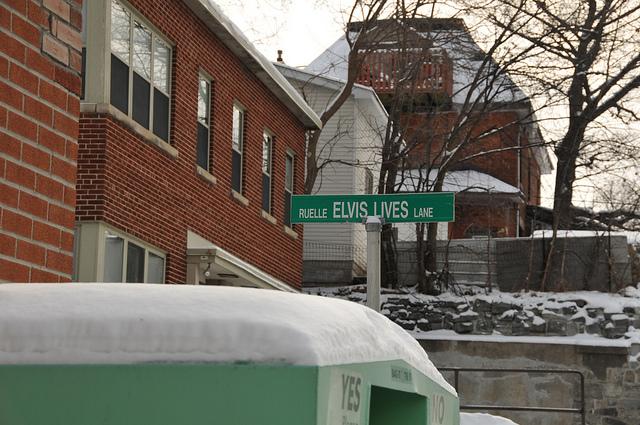What is the street sign referring too?
Be succinct. Elvis. What color is the street sign?
Short answer required. Green. What is the building made of?
Be succinct. Brick. 